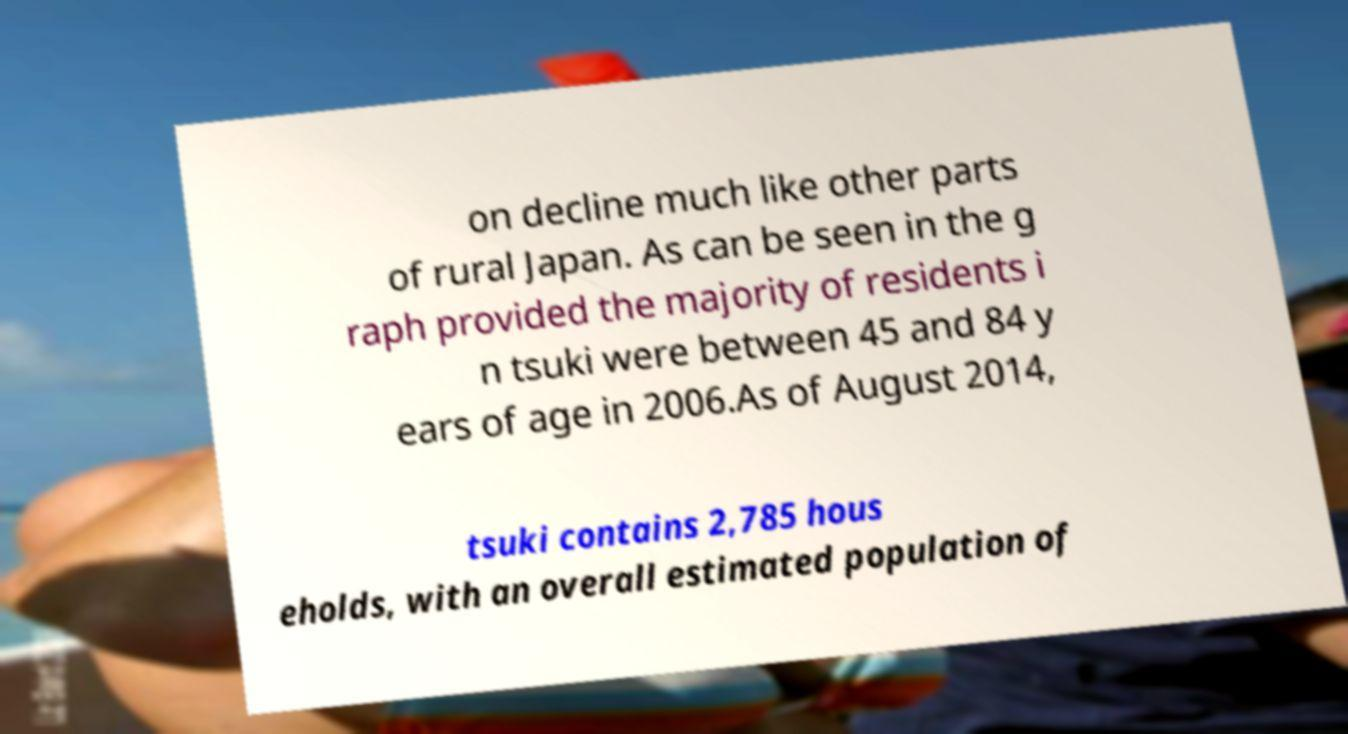There's text embedded in this image that I need extracted. Can you transcribe it verbatim? on decline much like other parts of rural Japan. As can be seen in the g raph provided the majority of residents i n tsuki were between 45 and 84 y ears of age in 2006.As of August 2014, tsuki contains 2,785 hous eholds, with an overall estimated population of 